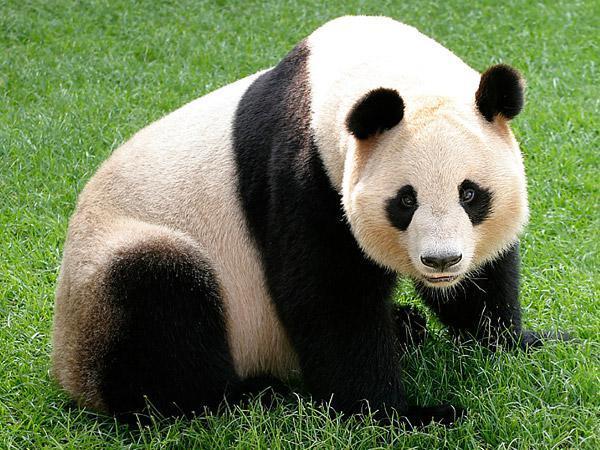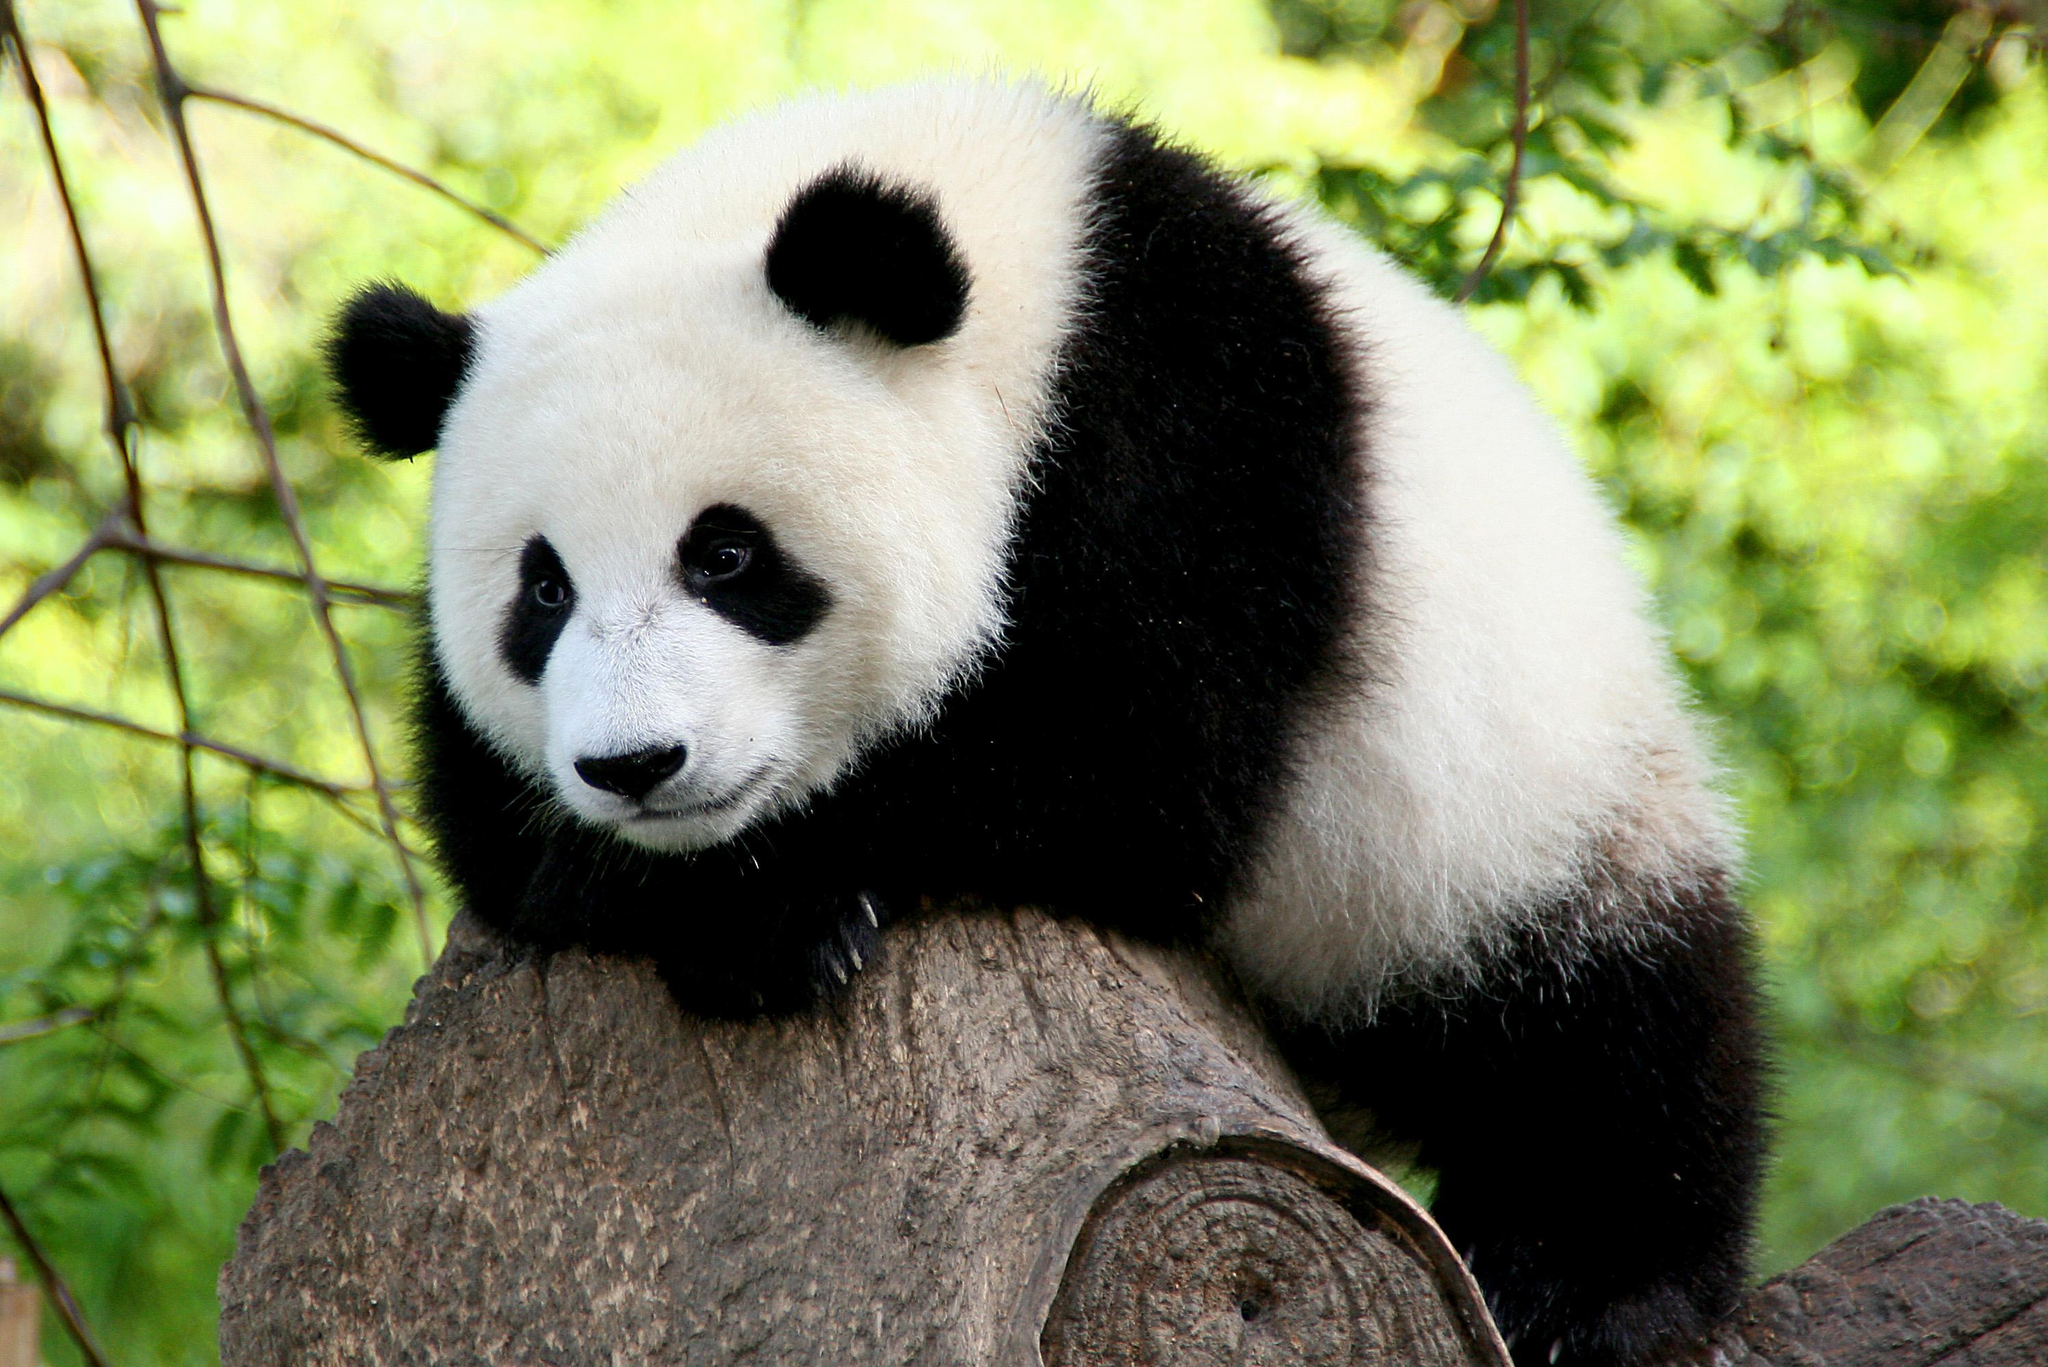The first image is the image on the left, the second image is the image on the right. Assess this claim about the two images: "There are two pandas in the image on the right.". Correct or not? Answer yes or no. No. 